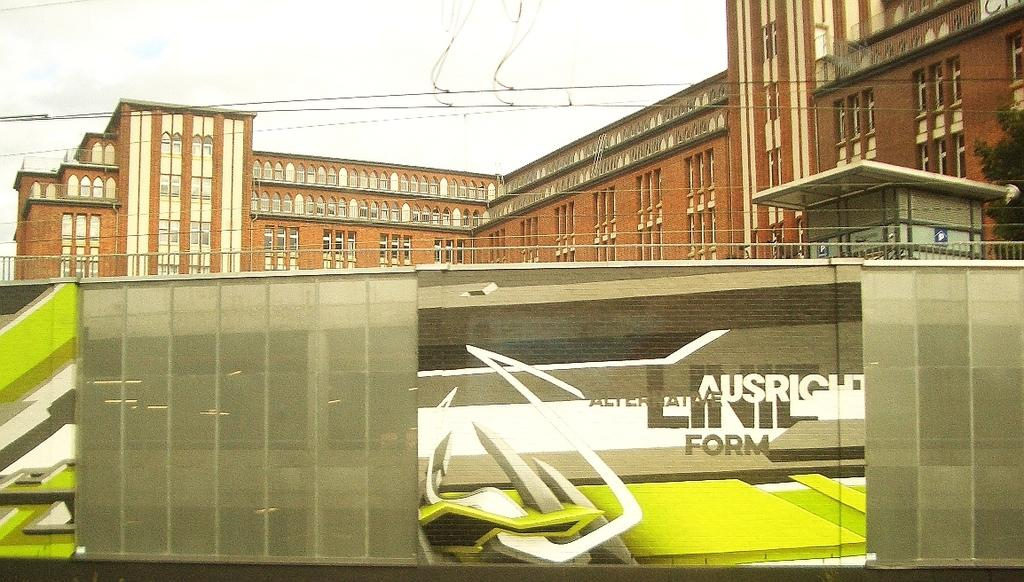What is the main structure visible in the image? There is a massive building behind the wall in the image. What features can be observed on the building? The building has many windows and doors. What is the purpose of the wall in the image? The wall serves as a barrier or boundary in front of the building. What is visible above the wall? There is fencing above the wall. What can be seen in the background of the image? The sky is visible in the background of the image. How many volleyballs can be seen on the roof of the building in the image? There are no volleyballs visible on the roof of the building in the image. Are there any lizards crawling on the wall in the image? There is no mention of lizards in the image, and they are not visible in the provided facts. 